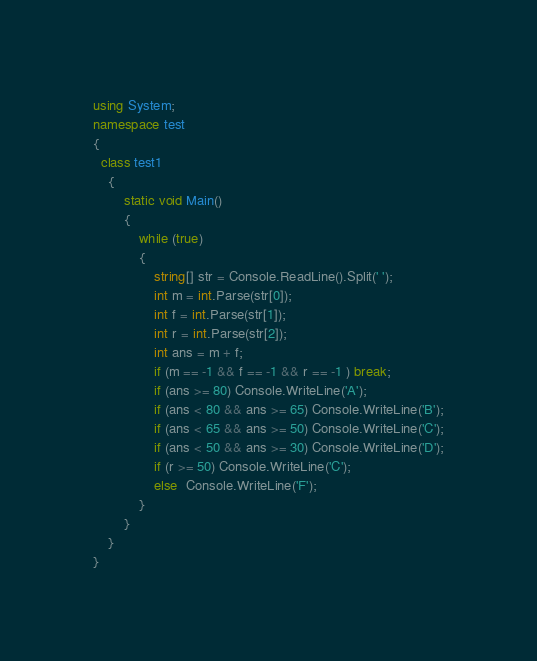Convert code to text. <code><loc_0><loc_0><loc_500><loc_500><_C#_>using System;
namespace test
{
  class test1
    {
        static void Main()
        {
            while (true)
            {
                string[] str = Console.ReadLine().Split(' ');
                int m = int.Parse(str[0]);
                int f = int.Parse(str[1]);
                int r = int.Parse(str[2]);
                int ans = m + f;
                if (m == -1 && f == -1 && r == -1 ) break;
                if (ans >= 80) Console.WriteLine('A');
                if (ans < 80 && ans >= 65) Console.WriteLine('B');
                if (ans < 65 && ans >= 50) Console.WriteLine('C');
                if (ans < 50 && ans >= 30) Console.WriteLine('D');
                if (r >= 50) Console.WriteLine('C');
                else  Console.WriteLine('F');
            }
        }
    }
}</code> 